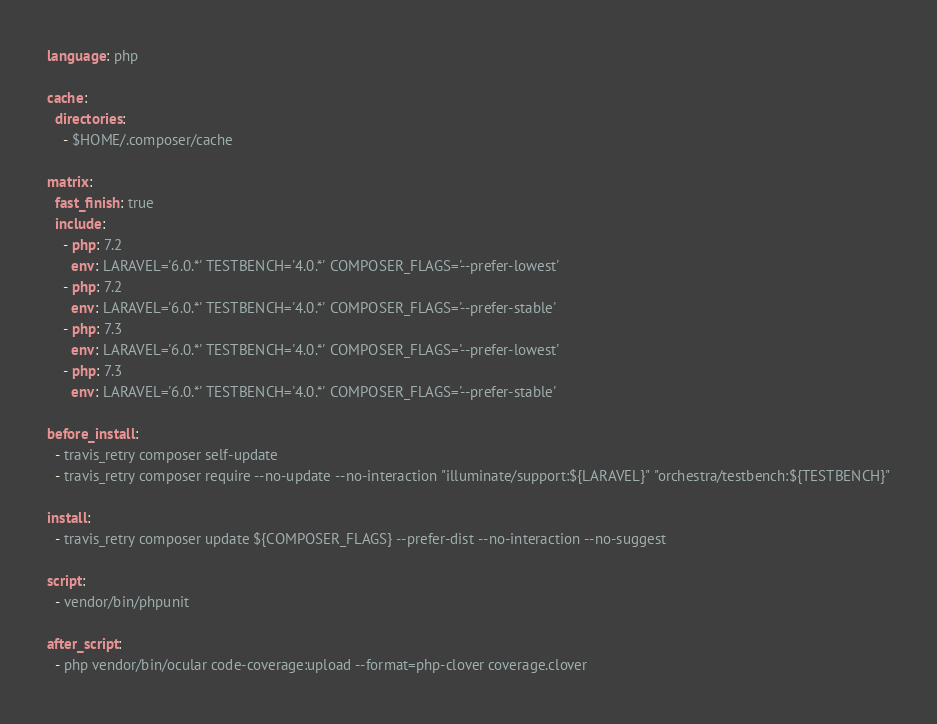Convert code to text. <code><loc_0><loc_0><loc_500><loc_500><_YAML_>language: php

cache:
  directories:
    - $HOME/.composer/cache

matrix:
  fast_finish: true
  include:
    - php: 7.2
      env: LARAVEL='6.0.*' TESTBENCH='4.0.*' COMPOSER_FLAGS='--prefer-lowest'
    - php: 7.2
      env: LARAVEL='6.0.*' TESTBENCH='4.0.*' COMPOSER_FLAGS='--prefer-stable'
    - php: 7.3
      env: LARAVEL='6.0.*' TESTBENCH='4.0.*' COMPOSER_FLAGS='--prefer-lowest'
    - php: 7.3
      env: LARAVEL='6.0.*' TESTBENCH='4.0.*' COMPOSER_FLAGS='--prefer-stable'

before_install:
  - travis_retry composer self-update
  - travis_retry composer require --no-update --no-interaction "illuminate/support:${LARAVEL}" "orchestra/testbench:${TESTBENCH}"

install:
  - travis_retry composer update ${COMPOSER_FLAGS} --prefer-dist --no-interaction --no-suggest

script:
  - vendor/bin/phpunit

after_script:
  - php vendor/bin/ocular code-coverage:upload --format=php-clover coverage.clover
</code> 